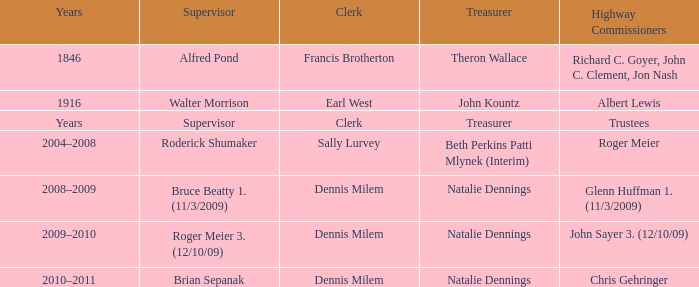Who was the overseer in the year 1846? Alfred Pond. 